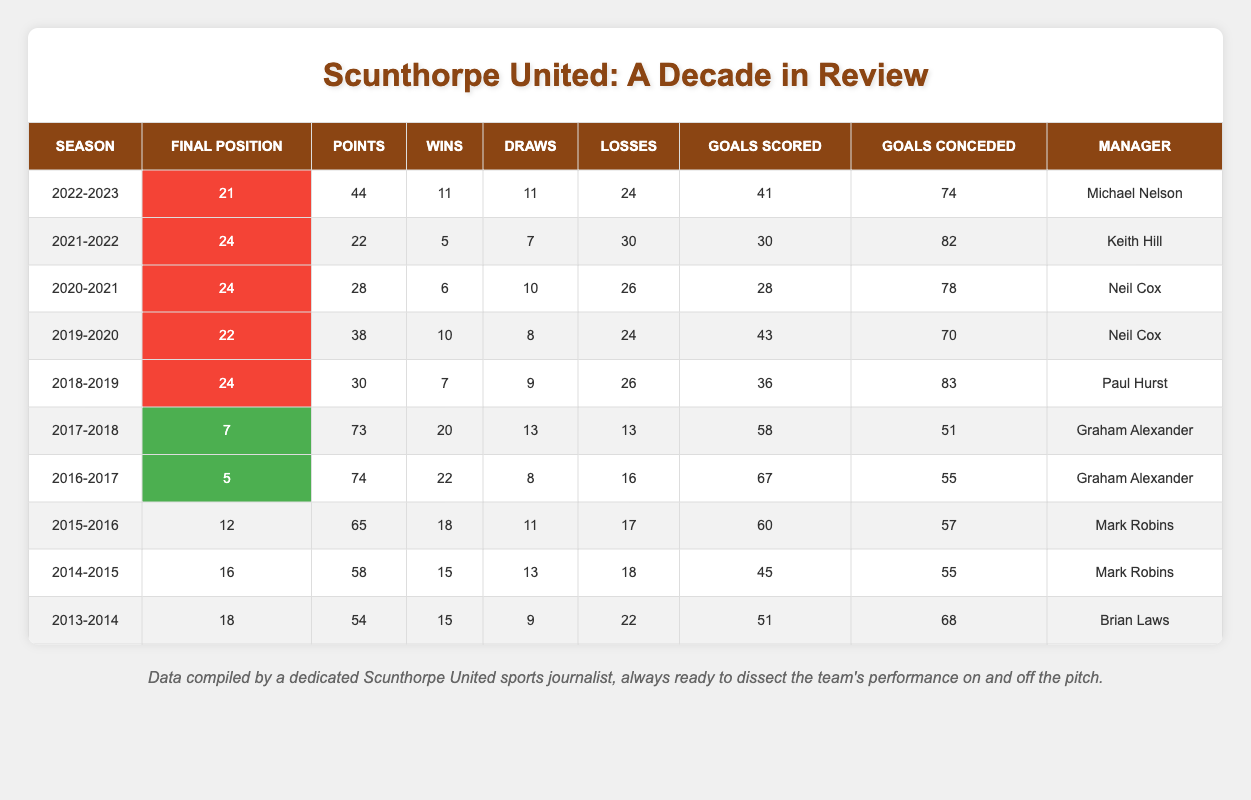What was Scunthorpe United's final position in the 2018-2019 season? According to the table, the entry for the 2018-2019 season shows a final position of 24.
Answer: 24 How many points did Scunthorpe United earn in the 2016-2017 season? Referring to the 2016-2017 entry in the table, it indicates that they earned 74 points.
Answer: 74 What was the average number of goals scored by Scunthorpe United over the last decade? To find the average, add the goals scored from all seasons: 51 + 45 + 60 + 67 + 58 + 36 + 43 + 28 + 30 + 41 =  457. There are 10 seasons, so 457/10 = 45.7.
Answer: 45.7 Did Scunthorpe United ever finish in the top 10 during the last decade? They finished in positions 5 and 7 in the 2016-2017 and 2017-2018 seasons respectively, both of which are in the top 10, thus the answer is yes.
Answer: Yes What was the difference in points earned between the 2016-2017 and 2022-2023 seasons? In the 2016-2017 season, Scunthorpe earned 74 points and in the 2022-2023 season, they earned 44 points. The difference is 74 - 44 = 30 points.
Answer: 30 How many wins did Scunthorpe United achieve in the 2019-2020 season? Looking at the 2019-2020 row, it shows that they secured 10 wins.
Answer: 10 Which season saw the most goals conceded, and how many were there? The 2018-2019 season resulted in the most goals conceded, with a total of 83.
Answer: 83 What was the total number of draws across all seasons in the last decade? Adding the draws from each season: 9 + 13 + 11 + 8 + 13 + 9 + 10 + 7 + 11 + 11 =  9 + 13 = 22; 22 + 11 = 33; 33 + 8 = 41; 41 + 13 = 54; 54 + 9 = 63; 63 + 10 = 73; 73 + 7 = 80; 80 + 11 = 91; 91 + 11 = 102. The total is 102 draws.
Answer: 102 In which year did they achieve their highest number of wins, and how many were there? The highest number of wins was in 2016-2017, where they achieved 22 wins.
Answer: 2016-2017, 22 